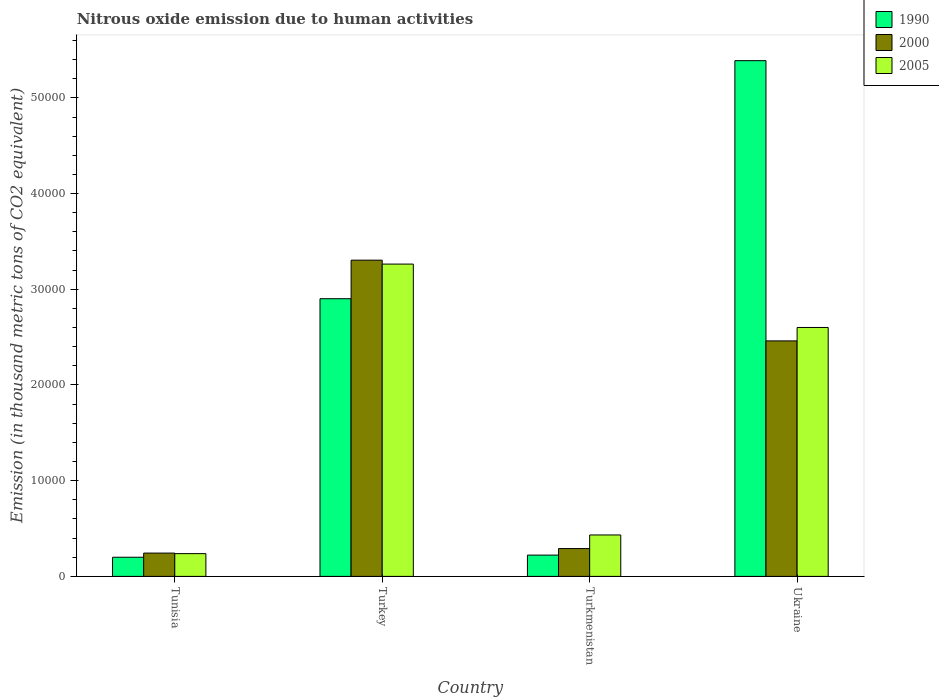How many different coloured bars are there?
Ensure brevity in your answer.  3. How many groups of bars are there?
Your response must be concise. 4. Are the number of bars per tick equal to the number of legend labels?
Your answer should be compact. Yes. How many bars are there on the 3rd tick from the left?
Provide a short and direct response. 3. What is the label of the 3rd group of bars from the left?
Ensure brevity in your answer.  Turkmenistan. In how many cases, is the number of bars for a given country not equal to the number of legend labels?
Provide a succinct answer. 0. What is the amount of nitrous oxide emitted in 2005 in Tunisia?
Ensure brevity in your answer.  2379.7. Across all countries, what is the maximum amount of nitrous oxide emitted in 2005?
Your answer should be compact. 3.26e+04. Across all countries, what is the minimum amount of nitrous oxide emitted in 2005?
Provide a short and direct response. 2379.7. In which country was the amount of nitrous oxide emitted in 1990 minimum?
Your answer should be very brief. Tunisia. What is the total amount of nitrous oxide emitted in 2005 in the graph?
Give a very brief answer. 6.53e+04. What is the difference between the amount of nitrous oxide emitted in 2000 in Tunisia and that in Ukraine?
Give a very brief answer. -2.22e+04. What is the difference between the amount of nitrous oxide emitted in 2000 in Tunisia and the amount of nitrous oxide emitted in 2005 in Turkey?
Provide a short and direct response. -3.02e+04. What is the average amount of nitrous oxide emitted in 2000 per country?
Provide a short and direct response. 1.57e+04. What is the difference between the amount of nitrous oxide emitted of/in 1990 and amount of nitrous oxide emitted of/in 2005 in Ukraine?
Give a very brief answer. 2.79e+04. In how many countries, is the amount of nitrous oxide emitted in 2000 greater than 32000 thousand metric tons?
Keep it short and to the point. 1. What is the ratio of the amount of nitrous oxide emitted in 1990 in Tunisia to that in Turkmenistan?
Provide a short and direct response. 0.9. Is the amount of nitrous oxide emitted in 2000 in Turkey less than that in Ukraine?
Keep it short and to the point. No. What is the difference between the highest and the second highest amount of nitrous oxide emitted in 2000?
Provide a short and direct response. 3.01e+04. What is the difference between the highest and the lowest amount of nitrous oxide emitted in 2005?
Your answer should be very brief. 3.03e+04. In how many countries, is the amount of nitrous oxide emitted in 2005 greater than the average amount of nitrous oxide emitted in 2005 taken over all countries?
Keep it short and to the point. 2. Is the sum of the amount of nitrous oxide emitted in 2000 in Tunisia and Turkey greater than the maximum amount of nitrous oxide emitted in 2005 across all countries?
Keep it short and to the point. Yes. What does the 3rd bar from the left in Turkmenistan represents?
Make the answer very short. 2005. What does the 2nd bar from the right in Turkmenistan represents?
Your response must be concise. 2000. Is it the case that in every country, the sum of the amount of nitrous oxide emitted in 1990 and amount of nitrous oxide emitted in 2000 is greater than the amount of nitrous oxide emitted in 2005?
Provide a short and direct response. Yes. How many bars are there?
Your answer should be very brief. 12. How many countries are there in the graph?
Offer a terse response. 4. Are the values on the major ticks of Y-axis written in scientific E-notation?
Offer a terse response. No. How many legend labels are there?
Your answer should be very brief. 3. How are the legend labels stacked?
Your response must be concise. Vertical. What is the title of the graph?
Provide a succinct answer. Nitrous oxide emission due to human activities. Does "1980" appear as one of the legend labels in the graph?
Make the answer very short. No. What is the label or title of the Y-axis?
Your answer should be very brief. Emission (in thousand metric tons of CO2 equivalent). What is the Emission (in thousand metric tons of CO2 equivalent) in 1990 in Tunisia?
Offer a terse response. 2001.7. What is the Emission (in thousand metric tons of CO2 equivalent) of 2000 in Tunisia?
Keep it short and to the point. 2436.9. What is the Emission (in thousand metric tons of CO2 equivalent) in 2005 in Tunisia?
Your answer should be compact. 2379.7. What is the Emission (in thousand metric tons of CO2 equivalent) of 1990 in Turkey?
Your response must be concise. 2.90e+04. What is the Emission (in thousand metric tons of CO2 equivalent) of 2000 in Turkey?
Provide a succinct answer. 3.30e+04. What is the Emission (in thousand metric tons of CO2 equivalent) of 2005 in Turkey?
Provide a short and direct response. 3.26e+04. What is the Emission (in thousand metric tons of CO2 equivalent) of 1990 in Turkmenistan?
Offer a terse response. 2225.1. What is the Emission (in thousand metric tons of CO2 equivalent) of 2000 in Turkmenistan?
Your response must be concise. 2907.9. What is the Emission (in thousand metric tons of CO2 equivalent) in 2005 in Turkmenistan?
Provide a short and direct response. 4330.6. What is the Emission (in thousand metric tons of CO2 equivalent) in 1990 in Ukraine?
Your response must be concise. 5.39e+04. What is the Emission (in thousand metric tons of CO2 equivalent) of 2000 in Ukraine?
Provide a succinct answer. 2.46e+04. What is the Emission (in thousand metric tons of CO2 equivalent) in 2005 in Ukraine?
Your answer should be compact. 2.60e+04. Across all countries, what is the maximum Emission (in thousand metric tons of CO2 equivalent) of 1990?
Give a very brief answer. 5.39e+04. Across all countries, what is the maximum Emission (in thousand metric tons of CO2 equivalent) of 2000?
Ensure brevity in your answer.  3.30e+04. Across all countries, what is the maximum Emission (in thousand metric tons of CO2 equivalent) in 2005?
Give a very brief answer. 3.26e+04. Across all countries, what is the minimum Emission (in thousand metric tons of CO2 equivalent) in 1990?
Offer a very short reply. 2001.7. Across all countries, what is the minimum Emission (in thousand metric tons of CO2 equivalent) of 2000?
Your answer should be compact. 2436.9. Across all countries, what is the minimum Emission (in thousand metric tons of CO2 equivalent) of 2005?
Your answer should be compact. 2379.7. What is the total Emission (in thousand metric tons of CO2 equivalent) in 1990 in the graph?
Keep it short and to the point. 8.71e+04. What is the total Emission (in thousand metric tons of CO2 equivalent) of 2000 in the graph?
Your response must be concise. 6.30e+04. What is the total Emission (in thousand metric tons of CO2 equivalent) in 2005 in the graph?
Ensure brevity in your answer.  6.53e+04. What is the difference between the Emission (in thousand metric tons of CO2 equivalent) in 1990 in Tunisia and that in Turkey?
Make the answer very short. -2.70e+04. What is the difference between the Emission (in thousand metric tons of CO2 equivalent) of 2000 in Tunisia and that in Turkey?
Offer a very short reply. -3.06e+04. What is the difference between the Emission (in thousand metric tons of CO2 equivalent) of 2005 in Tunisia and that in Turkey?
Give a very brief answer. -3.03e+04. What is the difference between the Emission (in thousand metric tons of CO2 equivalent) in 1990 in Tunisia and that in Turkmenistan?
Ensure brevity in your answer.  -223.4. What is the difference between the Emission (in thousand metric tons of CO2 equivalent) in 2000 in Tunisia and that in Turkmenistan?
Your answer should be very brief. -471. What is the difference between the Emission (in thousand metric tons of CO2 equivalent) in 2005 in Tunisia and that in Turkmenistan?
Your response must be concise. -1950.9. What is the difference between the Emission (in thousand metric tons of CO2 equivalent) of 1990 in Tunisia and that in Ukraine?
Keep it short and to the point. -5.19e+04. What is the difference between the Emission (in thousand metric tons of CO2 equivalent) of 2000 in Tunisia and that in Ukraine?
Make the answer very short. -2.22e+04. What is the difference between the Emission (in thousand metric tons of CO2 equivalent) of 2005 in Tunisia and that in Ukraine?
Your answer should be compact. -2.36e+04. What is the difference between the Emission (in thousand metric tons of CO2 equivalent) of 1990 in Turkey and that in Turkmenistan?
Your response must be concise. 2.68e+04. What is the difference between the Emission (in thousand metric tons of CO2 equivalent) in 2000 in Turkey and that in Turkmenistan?
Provide a succinct answer. 3.01e+04. What is the difference between the Emission (in thousand metric tons of CO2 equivalent) of 2005 in Turkey and that in Turkmenistan?
Offer a terse response. 2.83e+04. What is the difference between the Emission (in thousand metric tons of CO2 equivalent) in 1990 in Turkey and that in Ukraine?
Make the answer very short. -2.49e+04. What is the difference between the Emission (in thousand metric tons of CO2 equivalent) in 2000 in Turkey and that in Ukraine?
Provide a short and direct response. 8435.4. What is the difference between the Emission (in thousand metric tons of CO2 equivalent) of 2005 in Turkey and that in Ukraine?
Your answer should be compact. 6623.1. What is the difference between the Emission (in thousand metric tons of CO2 equivalent) of 1990 in Turkmenistan and that in Ukraine?
Make the answer very short. -5.17e+04. What is the difference between the Emission (in thousand metric tons of CO2 equivalent) of 2000 in Turkmenistan and that in Ukraine?
Offer a terse response. -2.17e+04. What is the difference between the Emission (in thousand metric tons of CO2 equivalent) of 2005 in Turkmenistan and that in Ukraine?
Offer a terse response. -2.17e+04. What is the difference between the Emission (in thousand metric tons of CO2 equivalent) of 1990 in Tunisia and the Emission (in thousand metric tons of CO2 equivalent) of 2000 in Turkey?
Provide a succinct answer. -3.10e+04. What is the difference between the Emission (in thousand metric tons of CO2 equivalent) of 1990 in Tunisia and the Emission (in thousand metric tons of CO2 equivalent) of 2005 in Turkey?
Offer a terse response. -3.06e+04. What is the difference between the Emission (in thousand metric tons of CO2 equivalent) in 2000 in Tunisia and the Emission (in thousand metric tons of CO2 equivalent) in 2005 in Turkey?
Provide a succinct answer. -3.02e+04. What is the difference between the Emission (in thousand metric tons of CO2 equivalent) of 1990 in Tunisia and the Emission (in thousand metric tons of CO2 equivalent) of 2000 in Turkmenistan?
Keep it short and to the point. -906.2. What is the difference between the Emission (in thousand metric tons of CO2 equivalent) of 1990 in Tunisia and the Emission (in thousand metric tons of CO2 equivalent) of 2005 in Turkmenistan?
Offer a terse response. -2328.9. What is the difference between the Emission (in thousand metric tons of CO2 equivalent) of 2000 in Tunisia and the Emission (in thousand metric tons of CO2 equivalent) of 2005 in Turkmenistan?
Provide a short and direct response. -1893.7. What is the difference between the Emission (in thousand metric tons of CO2 equivalent) in 1990 in Tunisia and the Emission (in thousand metric tons of CO2 equivalent) in 2000 in Ukraine?
Ensure brevity in your answer.  -2.26e+04. What is the difference between the Emission (in thousand metric tons of CO2 equivalent) in 1990 in Tunisia and the Emission (in thousand metric tons of CO2 equivalent) in 2005 in Ukraine?
Offer a terse response. -2.40e+04. What is the difference between the Emission (in thousand metric tons of CO2 equivalent) of 2000 in Tunisia and the Emission (in thousand metric tons of CO2 equivalent) of 2005 in Ukraine?
Give a very brief answer. -2.36e+04. What is the difference between the Emission (in thousand metric tons of CO2 equivalent) in 1990 in Turkey and the Emission (in thousand metric tons of CO2 equivalent) in 2000 in Turkmenistan?
Your response must be concise. 2.61e+04. What is the difference between the Emission (in thousand metric tons of CO2 equivalent) in 1990 in Turkey and the Emission (in thousand metric tons of CO2 equivalent) in 2005 in Turkmenistan?
Make the answer very short. 2.47e+04. What is the difference between the Emission (in thousand metric tons of CO2 equivalent) in 2000 in Turkey and the Emission (in thousand metric tons of CO2 equivalent) in 2005 in Turkmenistan?
Provide a short and direct response. 2.87e+04. What is the difference between the Emission (in thousand metric tons of CO2 equivalent) of 1990 in Turkey and the Emission (in thousand metric tons of CO2 equivalent) of 2000 in Ukraine?
Ensure brevity in your answer.  4407.8. What is the difference between the Emission (in thousand metric tons of CO2 equivalent) of 1990 in Turkey and the Emission (in thousand metric tons of CO2 equivalent) of 2005 in Ukraine?
Make the answer very short. 3005.7. What is the difference between the Emission (in thousand metric tons of CO2 equivalent) of 2000 in Turkey and the Emission (in thousand metric tons of CO2 equivalent) of 2005 in Ukraine?
Offer a terse response. 7033.3. What is the difference between the Emission (in thousand metric tons of CO2 equivalent) of 1990 in Turkmenistan and the Emission (in thousand metric tons of CO2 equivalent) of 2000 in Ukraine?
Your answer should be very brief. -2.24e+04. What is the difference between the Emission (in thousand metric tons of CO2 equivalent) of 1990 in Turkmenistan and the Emission (in thousand metric tons of CO2 equivalent) of 2005 in Ukraine?
Your answer should be compact. -2.38e+04. What is the difference between the Emission (in thousand metric tons of CO2 equivalent) of 2000 in Turkmenistan and the Emission (in thousand metric tons of CO2 equivalent) of 2005 in Ukraine?
Your response must be concise. -2.31e+04. What is the average Emission (in thousand metric tons of CO2 equivalent) in 1990 per country?
Give a very brief answer. 2.18e+04. What is the average Emission (in thousand metric tons of CO2 equivalent) of 2000 per country?
Make the answer very short. 1.57e+04. What is the average Emission (in thousand metric tons of CO2 equivalent) in 2005 per country?
Provide a short and direct response. 1.63e+04. What is the difference between the Emission (in thousand metric tons of CO2 equivalent) in 1990 and Emission (in thousand metric tons of CO2 equivalent) in 2000 in Tunisia?
Your response must be concise. -435.2. What is the difference between the Emission (in thousand metric tons of CO2 equivalent) of 1990 and Emission (in thousand metric tons of CO2 equivalent) of 2005 in Tunisia?
Keep it short and to the point. -378. What is the difference between the Emission (in thousand metric tons of CO2 equivalent) of 2000 and Emission (in thousand metric tons of CO2 equivalent) of 2005 in Tunisia?
Ensure brevity in your answer.  57.2. What is the difference between the Emission (in thousand metric tons of CO2 equivalent) in 1990 and Emission (in thousand metric tons of CO2 equivalent) in 2000 in Turkey?
Your answer should be compact. -4027.6. What is the difference between the Emission (in thousand metric tons of CO2 equivalent) of 1990 and Emission (in thousand metric tons of CO2 equivalent) of 2005 in Turkey?
Offer a terse response. -3617.4. What is the difference between the Emission (in thousand metric tons of CO2 equivalent) of 2000 and Emission (in thousand metric tons of CO2 equivalent) of 2005 in Turkey?
Keep it short and to the point. 410.2. What is the difference between the Emission (in thousand metric tons of CO2 equivalent) of 1990 and Emission (in thousand metric tons of CO2 equivalent) of 2000 in Turkmenistan?
Ensure brevity in your answer.  -682.8. What is the difference between the Emission (in thousand metric tons of CO2 equivalent) in 1990 and Emission (in thousand metric tons of CO2 equivalent) in 2005 in Turkmenistan?
Offer a terse response. -2105.5. What is the difference between the Emission (in thousand metric tons of CO2 equivalent) of 2000 and Emission (in thousand metric tons of CO2 equivalent) of 2005 in Turkmenistan?
Offer a very short reply. -1422.7. What is the difference between the Emission (in thousand metric tons of CO2 equivalent) in 1990 and Emission (in thousand metric tons of CO2 equivalent) in 2000 in Ukraine?
Make the answer very short. 2.93e+04. What is the difference between the Emission (in thousand metric tons of CO2 equivalent) in 1990 and Emission (in thousand metric tons of CO2 equivalent) in 2005 in Ukraine?
Make the answer very short. 2.79e+04. What is the difference between the Emission (in thousand metric tons of CO2 equivalent) of 2000 and Emission (in thousand metric tons of CO2 equivalent) of 2005 in Ukraine?
Make the answer very short. -1402.1. What is the ratio of the Emission (in thousand metric tons of CO2 equivalent) in 1990 in Tunisia to that in Turkey?
Your answer should be very brief. 0.07. What is the ratio of the Emission (in thousand metric tons of CO2 equivalent) of 2000 in Tunisia to that in Turkey?
Provide a succinct answer. 0.07. What is the ratio of the Emission (in thousand metric tons of CO2 equivalent) of 2005 in Tunisia to that in Turkey?
Your answer should be compact. 0.07. What is the ratio of the Emission (in thousand metric tons of CO2 equivalent) of 1990 in Tunisia to that in Turkmenistan?
Offer a terse response. 0.9. What is the ratio of the Emission (in thousand metric tons of CO2 equivalent) of 2000 in Tunisia to that in Turkmenistan?
Provide a short and direct response. 0.84. What is the ratio of the Emission (in thousand metric tons of CO2 equivalent) in 2005 in Tunisia to that in Turkmenistan?
Make the answer very short. 0.55. What is the ratio of the Emission (in thousand metric tons of CO2 equivalent) of 1990 in Tunisia to that in Ukraine?
Provide a short and direct response. 0.04. What is the ratio of the Emission (in thousand metric tons of CO2 equivalent) of 2000 in Tunisia to that in Ukraine?
Your answer should be very brief. 0.1. What is the ratio of the Emission (in thousand metric tons of CO2 equivalent) of 2005 in Tunisia to that in Ukraine?
Make the answer very short. 0.09. What is the ratio of the Emission (in thousand metric tons of CO2 equivalent) of 1990 in Turkey to that in Turkmenistan?
Offer a terse response. 13.04. What is the ratio of the Emission (in thousand metric tons of CO2 equivalent) of 2000 in Turkey to that in Turkmenistan?
Give a very brief answer. 11.36. What is the ratio of the Emission (in thousand metric tons of CO2 equivalent) of 2005 in Turkey to that in Turkmenistan?
Offer a terse response. 7.54. What is the ratio of the Emission (in thousand metric tons of CO2 equivalent) of 1990 in Turkey to that in Ukraine?
Your response must be concise. 0.54. What is the ratio of the Emission (in thousand metric tons of CO2 equivalent) of 2000 in Turkey to that in Ukraine?
Keep it short and to the point. 1.34. What is the ratio of the Emission (in thousand metric tons of CO2 equivalent) of 2005 in Turkey to that in Ukraine?
Give a very brief answer. 1.25. What is the ratio of the Emission (in thousand metric tons of CO2 equivalent) of 1990 in Turkmenistan to that in Ukraine?
Provide a short and direct response. 0.04. What is the ratio of the Emission (in thousand metric tons of CO2 equivalent) in 2000 in Turkmenistan to that in Ukraine?
Your answer should be compact. 0.12. What is the ratio of the Emission (in thousand metric tons of CO2 equivalent) of 2005 in Turkmenistan to that in Ukraine?
Your answer should be compact. 0.17. What is the difference between the highest and the second highest Emission (in thousand metric tons of CO2 equivalent) of 1990?
Make the answer very short. 2.49e+04. What is the difference between the highest and the second highest Emission (in thousand metric tons of CO2 equivalent) of 2000?
Ensure brevity in your answer.  8435.4. What is the difference between the highest and the second highest Emission (in thousand metric tons of CO2 equivalent) of 2005?
Ensure brevity in your answer.  6623.1. What is the difference between the highest and the lowest Emission (in thousand metric tons of CO2 equivalent) of 1990?
Keep it short and to the point. 5.19e+04. What is the difference between the highest and the lowest Emission (in thousand metric tons of CO2 equivalent) in 2000?
Your response must be concise. 3.06e+04. What is the difference between the highest and the lowest Emission (in thousand metric tons of CO2 equivalent) in 2005?
Provide a short and direct response. 3.03e+04. 